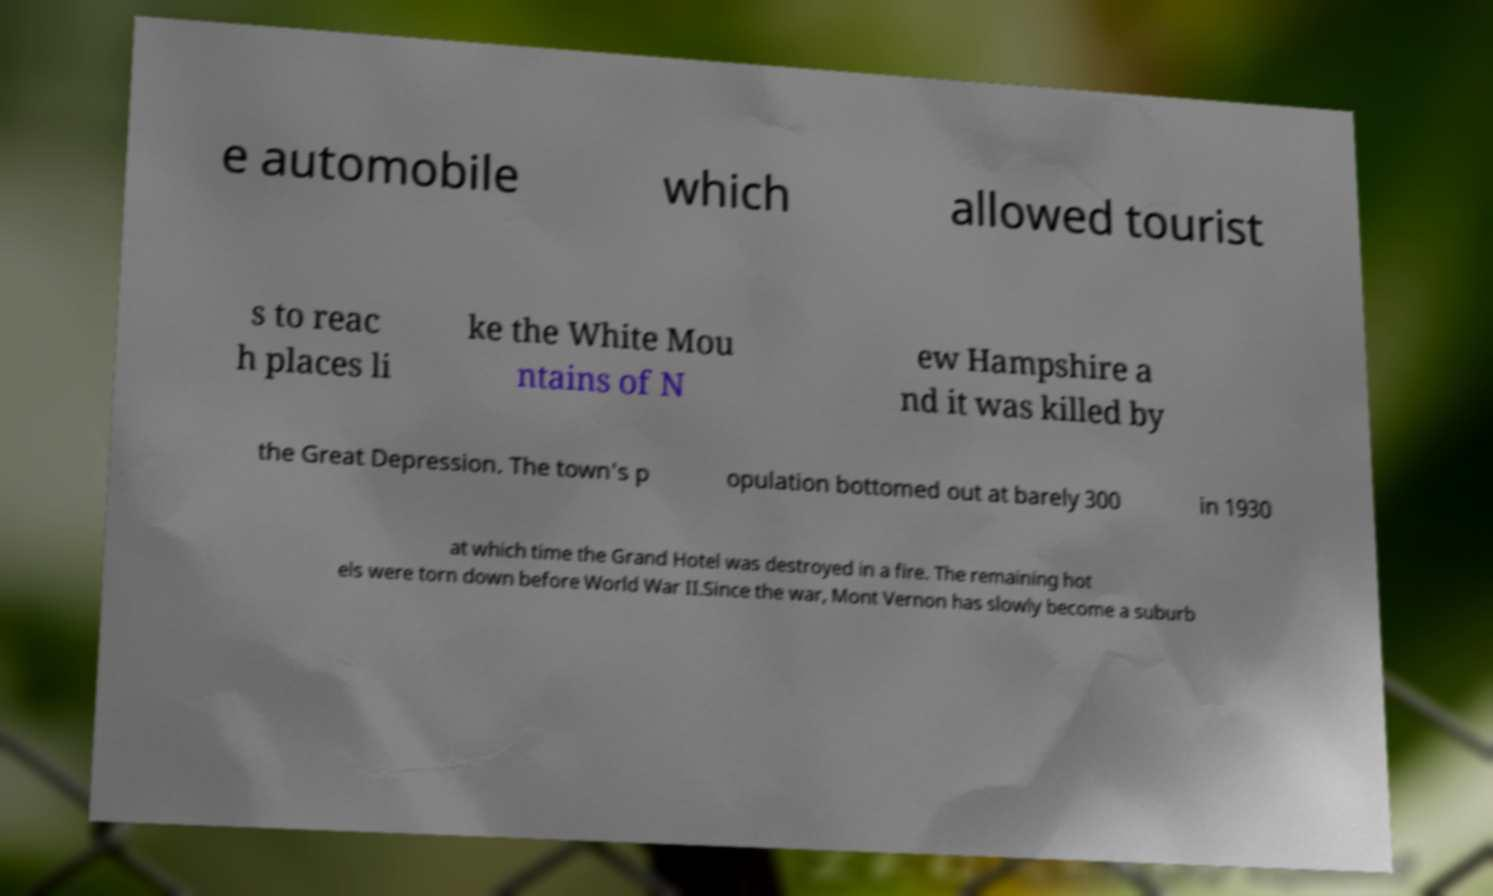Can you read and provide the text displayed in the image?This photo seems to have some interesting text. Can you extract and type it out for me? e automobile which allowed tourist s to reac h places li ke the White Mou ntains of N ew Hampshire a nd it was killed by the Great Depression. The town's p opulation bottomed out at barely 300 in 1930 at which time the Grand Hotel was destroyed in a fire. The remaining hot els were torn down before World War II.Since the war, Mont Vernon has slowly become a suburb 